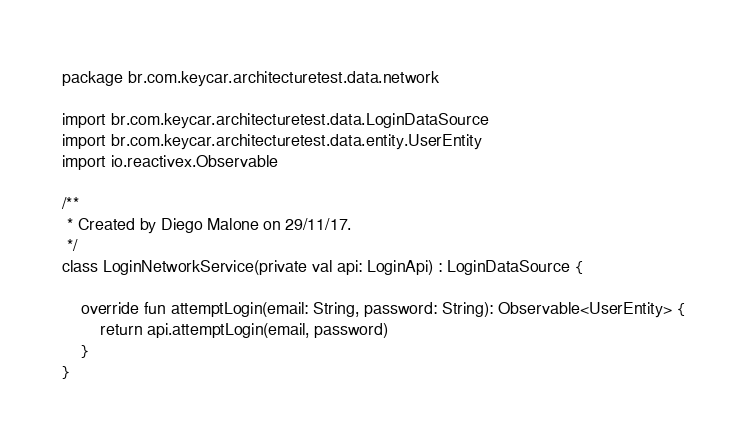<code> <loc_0><loc_0><loc_500><loc_500><_Kotlin_>package br.com.keycar.architecturetest.data.network

import br.com.keycar.architecturetest.data.LoginDataSource
import br.com.keycar.architecturetest.data.entity.UserEntity
import io.reactivex.Observable

/**
 * Created by Diego Malone on 29/11/17.
 */
class LoginNetworkService(private val api: LoginApi) : LoginDataSource {

    override fun attemptLogin(email: String, password: String): Observable<UserEntity> {
        return api.attemptLogin(email, password)
    }
}</code> 